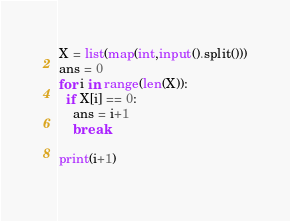Convert code to text. <code><loc_0><loc_0><loc_500><loc_500><_Python_>X = list(map(int,input().split()))
ans = 0
for i in range(len(X)):
  if X[i] == 0:
    ans = i+1
    break

print(i+1)
    </code> 